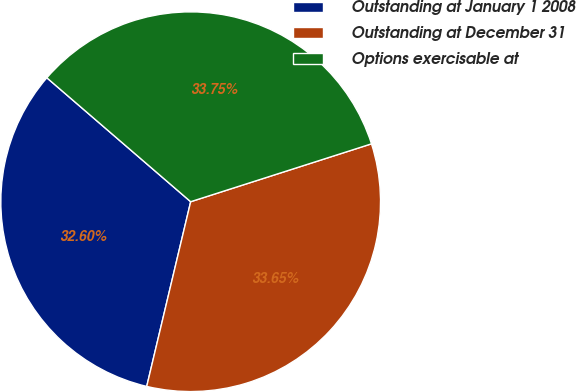Convert chart to OTSL. <chart><loc_0><loc_0><loc_500><loc_500><pie_chart><fcel>Outstanding at January 1 2008<fcel>Outstanding at December 31<fcel>Options exercisable at<nl><fcel>32.6%<fcel>33.65%<fcel>33.75%<nl></chart> 